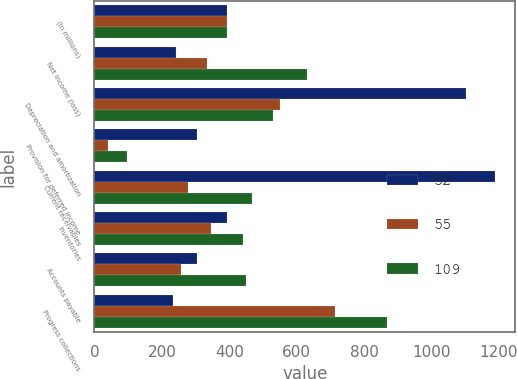<chart> <loc_0><loc_0><loc_500><loc_500><stacked_bar_chart><ecel><fcel>(In millions)<fcel>Net income (loss)<fcel>Depreciation and amortization<fcel>Provision for deferred income<fcel>Current receivables<fcel>Inventories<fcel>Accounts payable<fcel>Progress collections<nl><fcel>52<fcel>392<fcel>242<fcel>1103<fcel>304<fcel>1190<fcel>392<fcel>303<fcel>232<nl><fcel>55<fcel>392<fcel>334<fcel>550<fcel>39<fcel>278<fcel>345<fcel>256<fcel>714<nl><fcel>109<fcel>392<fcel>631<fcel>530<fcel>96<fcel>469<fcel>442<fcel>450<fcel>867<nl></chart> 